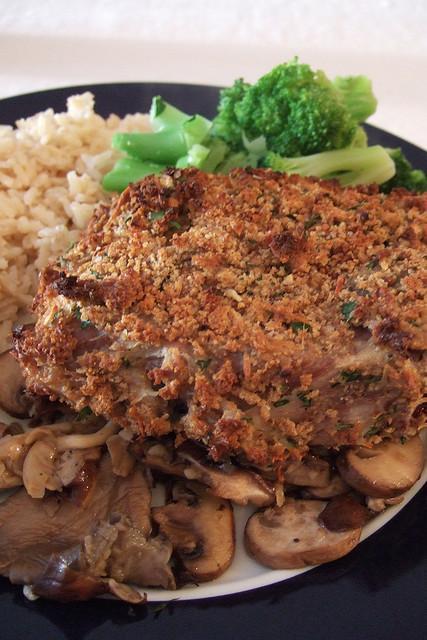How many spatula's are visible?
Give a very brief answer. 0. 